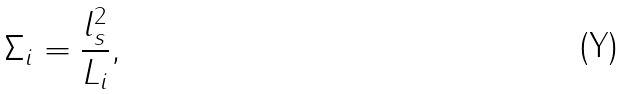<formula> <loc_0><loc_0><loc_500><loc_500>\Sigma _ { i } = \frac { l _ { s } ^ { 2 } } { L _ { i } } ,</formula> 